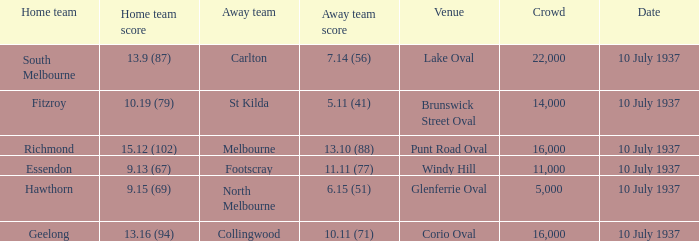What is the lowest Crowd with a Home Team Score of 9.15 (69)? 5000.0. 